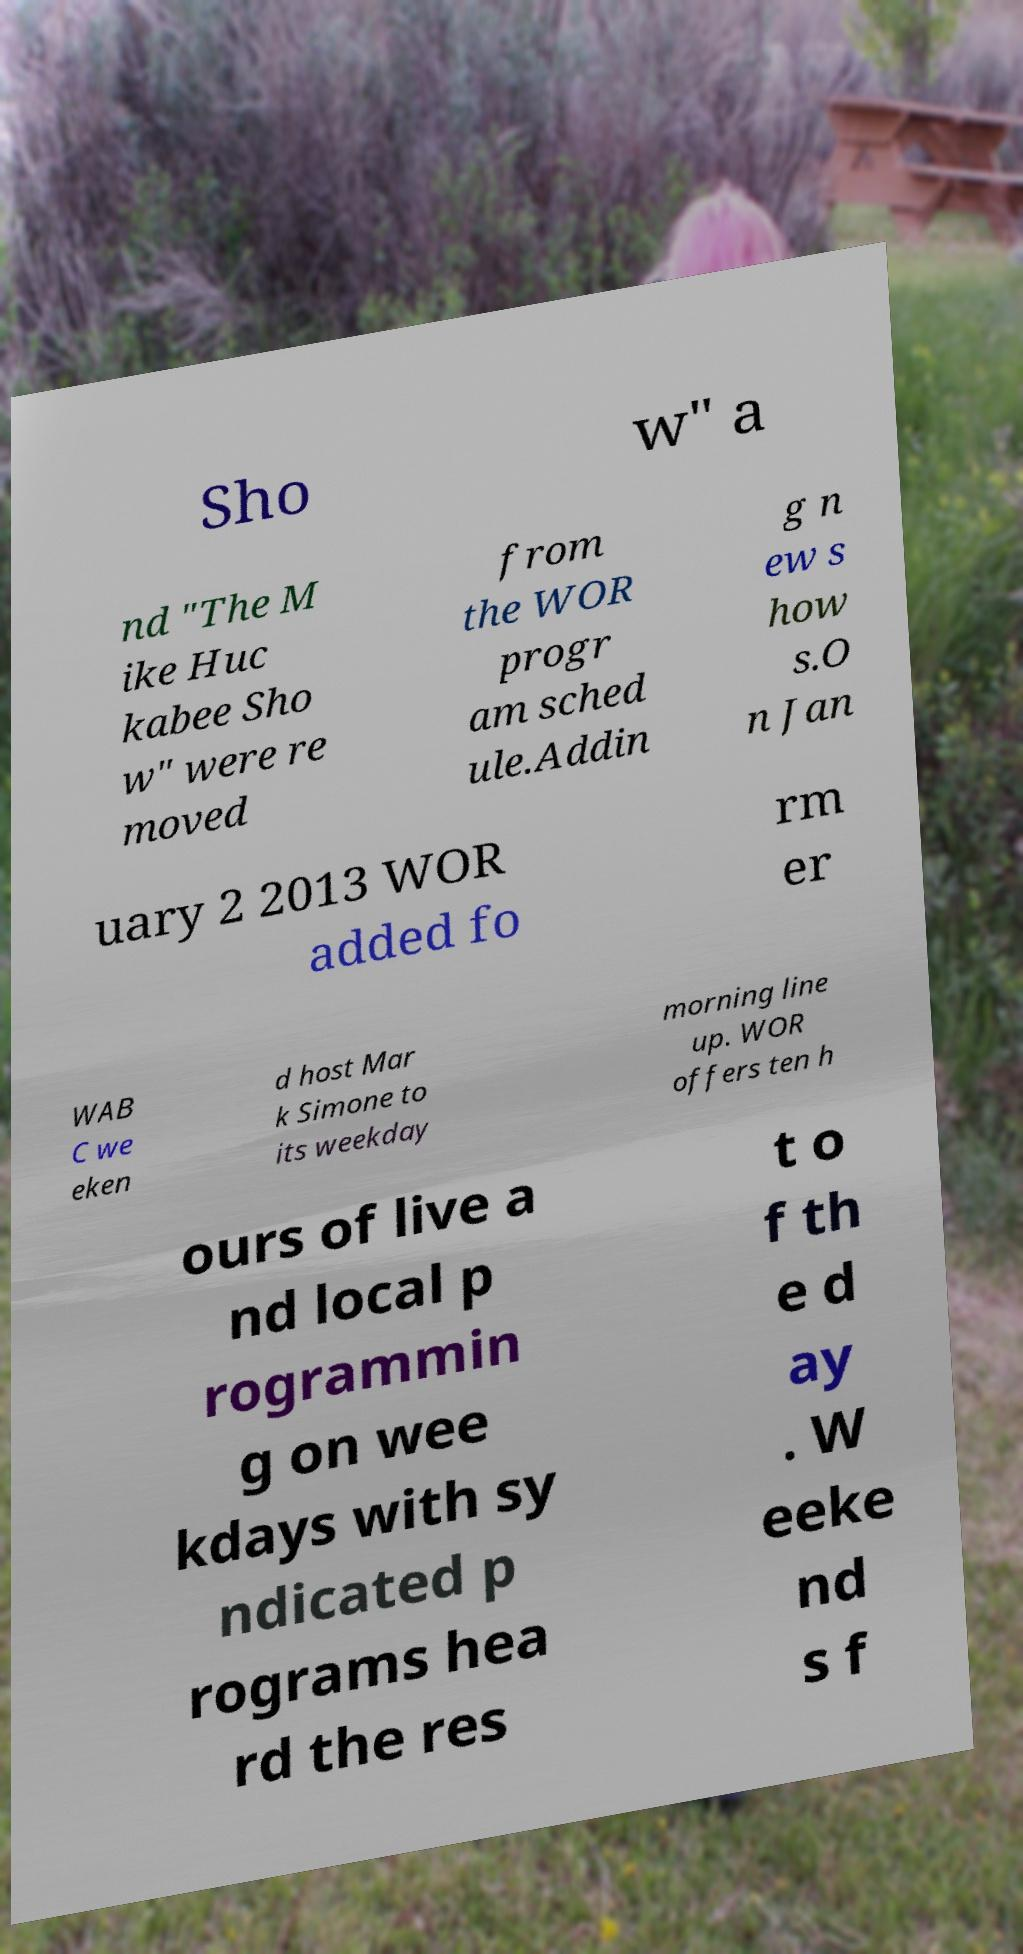There's text embedded in this image that I need extracted. Can you transcribe it verbatim? Sho w" a nd "The M ike Huc kabee Sho w" were re moved from the WOR progr am sched ule.Addin g n ew s how s.O n Jan uary 2 2013 WOR added fo rm er WAB C we eken d host Mar k Simone to its weekday morning line up. WOR offers ten h ours of live a nd local p rogrammin g on wee kdays with sy ndicated p rograms hea rd the res t o f th e d ay . W eeke nd s f 